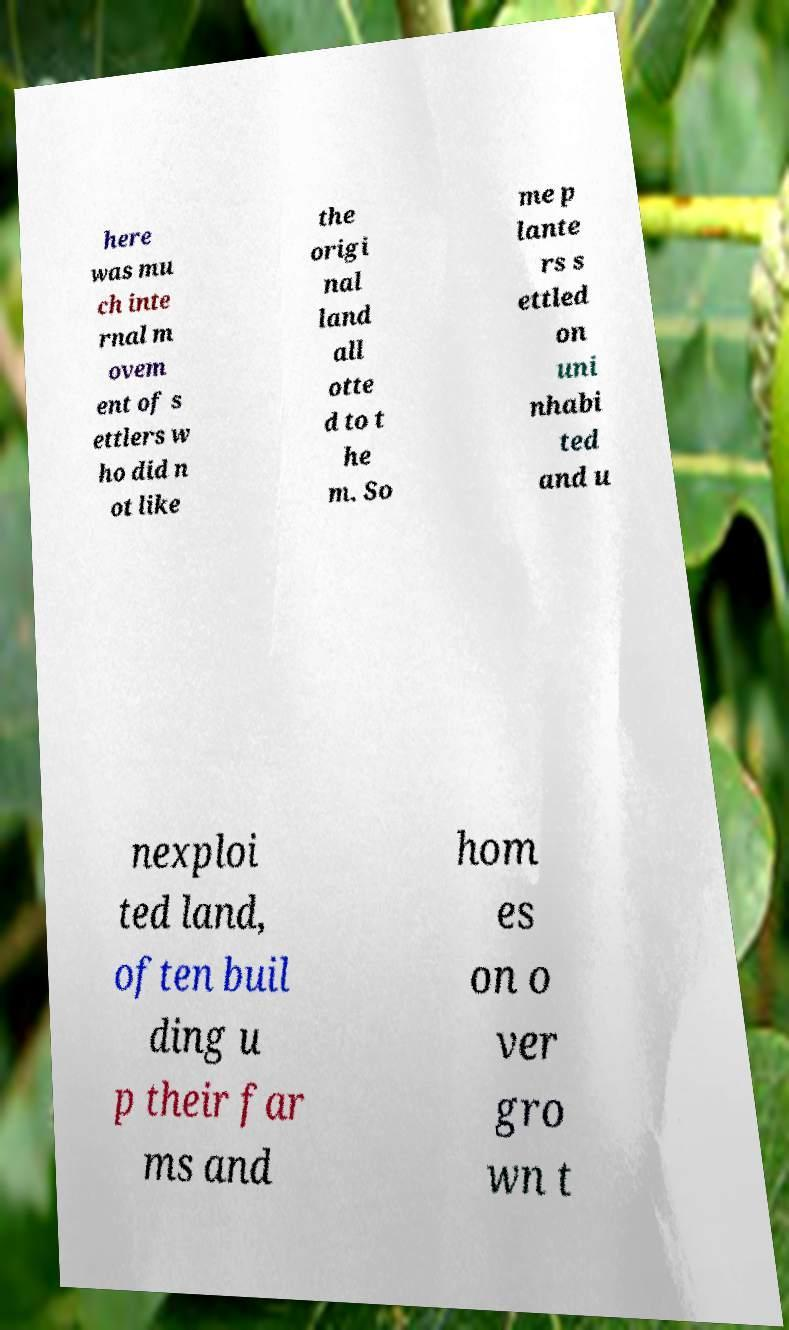I need the written content from this picture converted into text. Can you do that? here was mu ch inte rnal m ovem ent of s ettlers w ho did n ot like the origi nal land all otte d to t he m. So me p lante rs s ettled on uni nhabi ted and u nexploi ted land, often buil ding u p their far ms and hom es on o ver gro wn t 